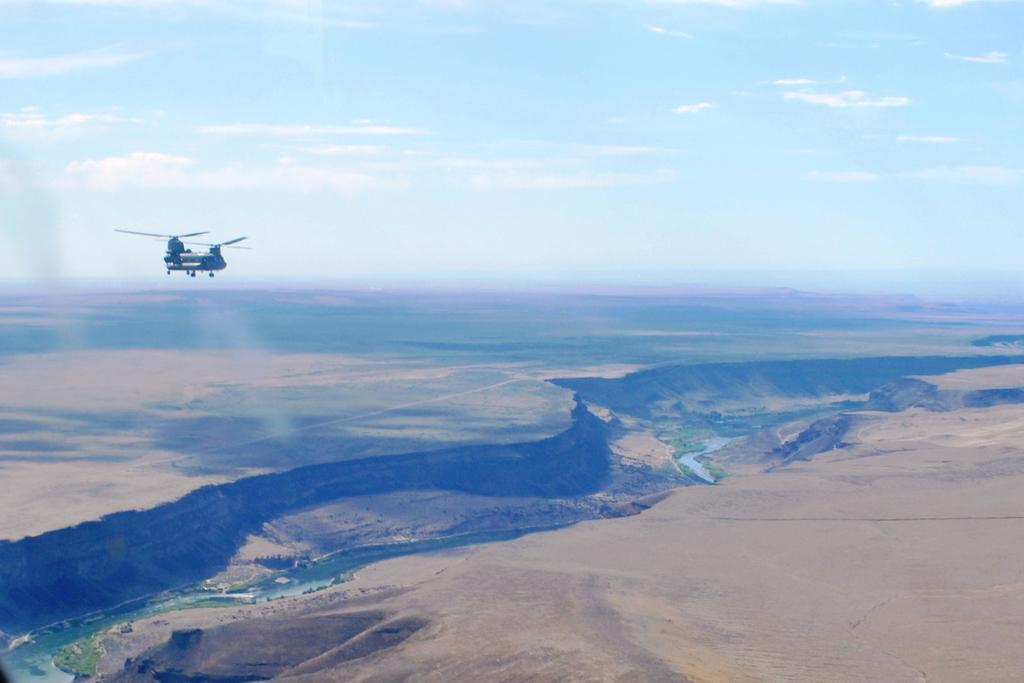What is flying in the air in the image? There is a helicopter in the air in the image. What type of terrain is visible in the image? There is water and sand visible in the image. What is present in the sky in the image? There are clouds in the sky at the top of the image. What type of comb is being used to style the leg in the image? There is no leg or comb present in the image. 